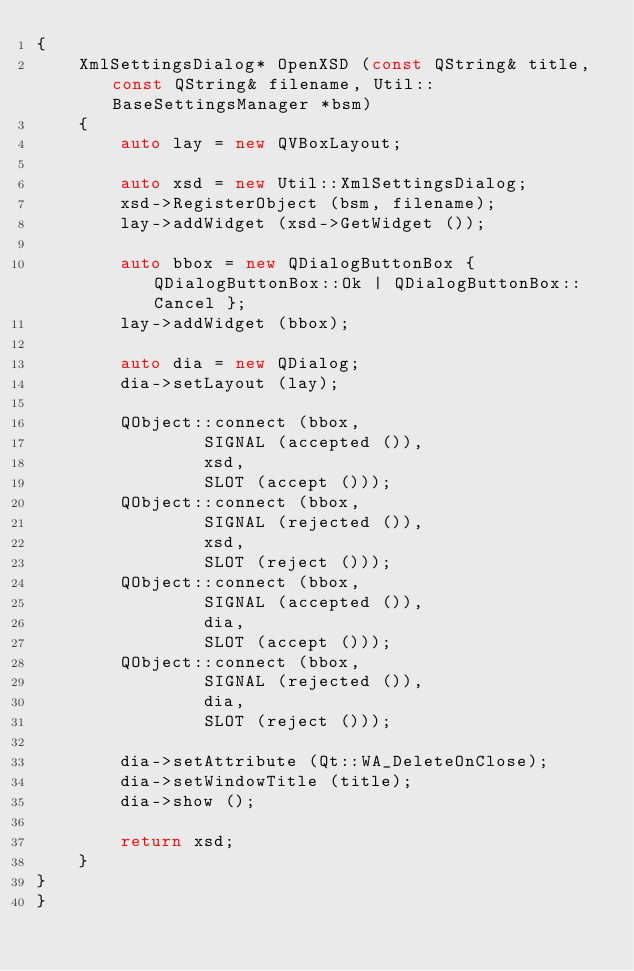<code> <loc_0><loc_0><loc_500><loc_500><_C++_>{
	XmlSettingsDialog* OpenXSD (const QString& title, const QString& filename, Util::BaseSettingsManager *bsm)
	{
		auto lay = new QVBoxLayout;

		auto xsd = new Util::XmlSettingsDialog;
		xsd->RegisterObject (bsm, filename);
		lay->addWidget (xsd->GetWidget ());

		auto bbox = new QDialogButtonBox { QDialogButtonBox::Ok | QDialogButtonBox::Cancel };
		lay->addWidget (bbox);

		auto dia = new QDialog;
		dia->setLayout (lay);

		QObject::connect (bbox,
				SIGNAL (accepted ()),
				xsd,
				SLOT (accept ()));
		QObject::connect (bbox,
				SIGNAL (rejected ()),
				xsd,
				SLOT (reject ()));
		QObject::connect (bbox,
				SIGNAL (accepted ()),
				dia,
				SLOT (accept ()));
		QObject::connect (bbox,
				SIGNAL (rejected ()),
				dia,
				SLOT (reject ()));

		dia->setAttribute (Qt::WA_DeleteOnClose);
		dia->setWindowTitle (title);
		dia->show ();

		return xsd;
	}
}
}
</code> 